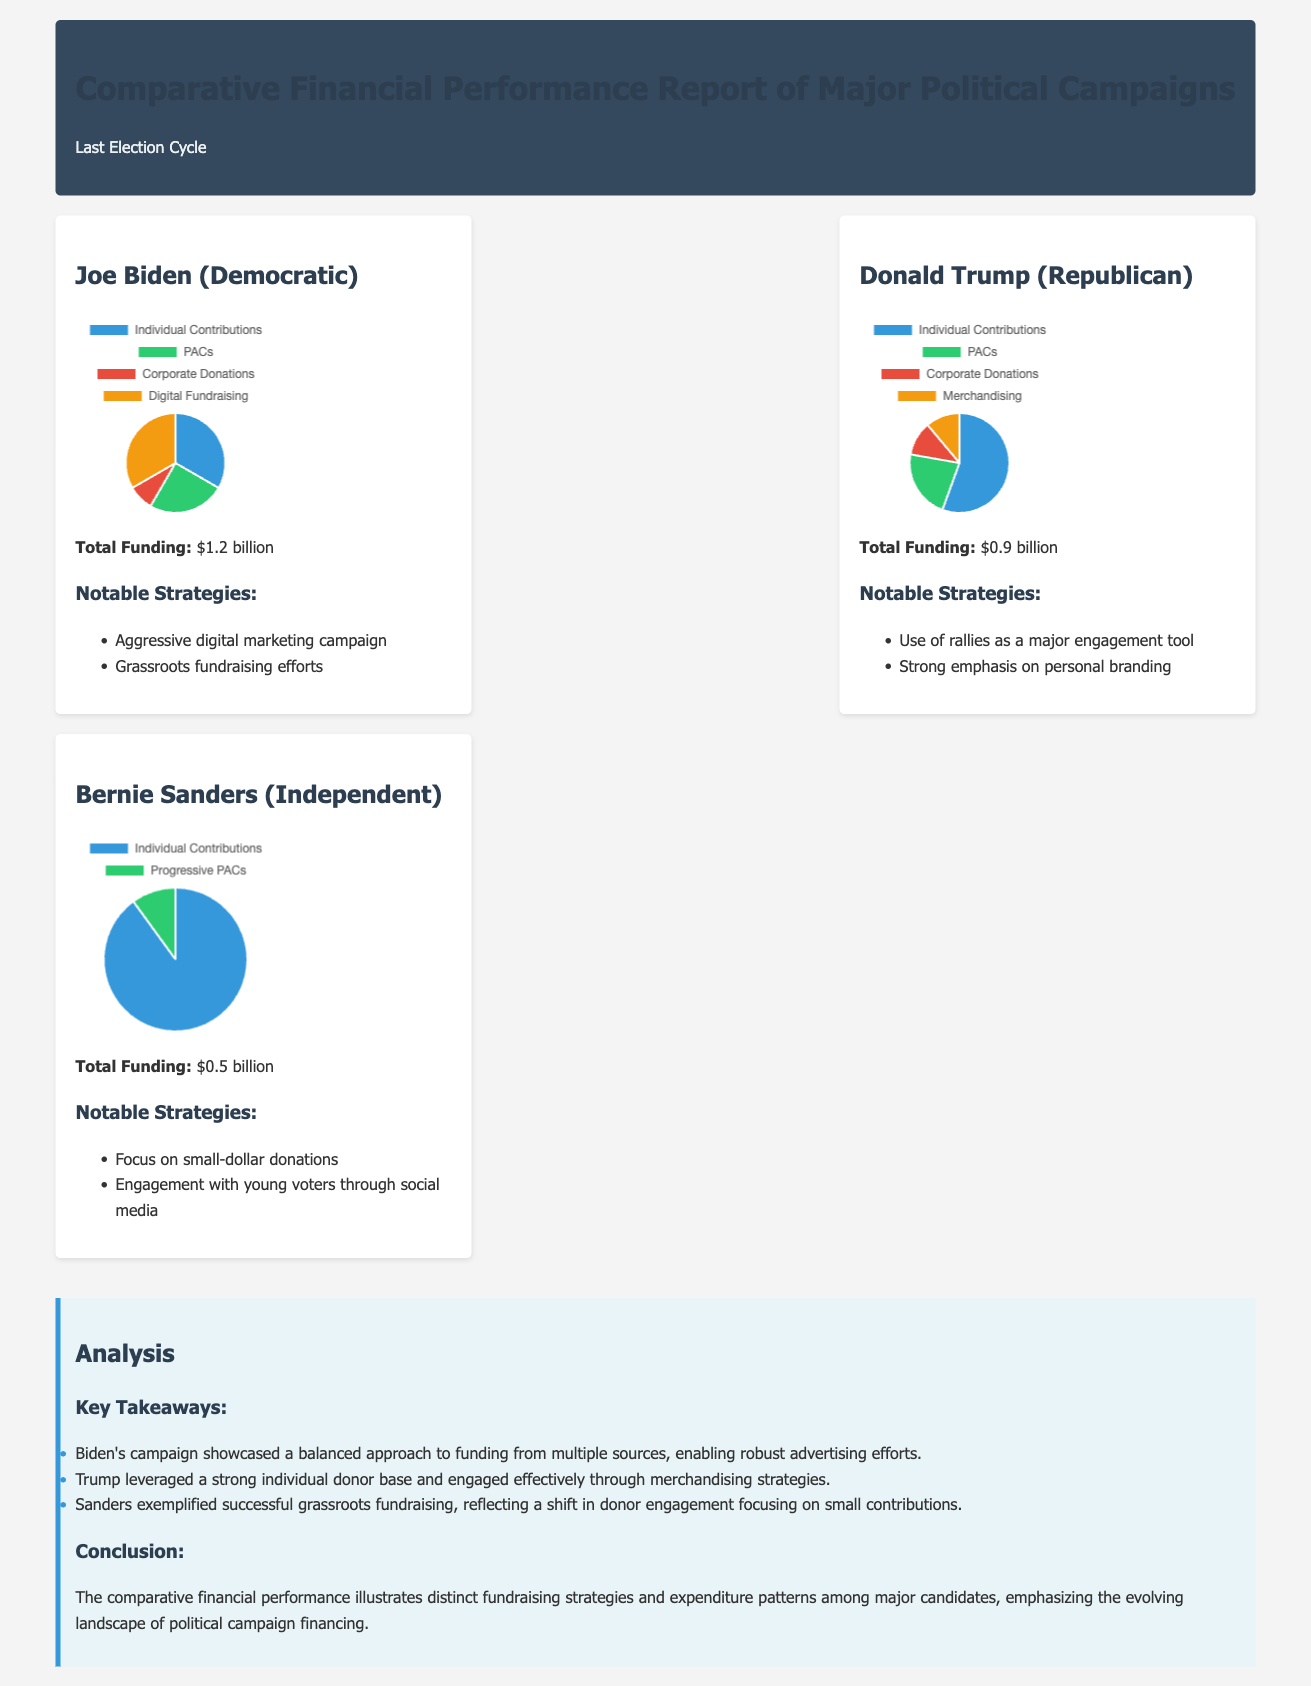What is Joe Biden's total funding? The document states that Joe Biden's total funding is $1.2 billion.
Answer: $1.2 billion What is Donald Trump's notable strategy? One of the notable strategies for Donald Trump's campaign mentioned in the document is the use of rallies as a major engagement tool.
Answer: Use of rallies How much funding did Bernie Sanders receive? According to the document, Bernie Sanders received a total of $0.5 billion in funding.
Answer: $0.5 billion Which candidate had the highest individual contributions? The document indicates that Donald Trump had the highest individual contributions at $500 million.
Answer: Donald Trump What type of funding does Joe Biden rely on most? The document mentions that Joe Biden's campaign funding sources include individual contributions as the largest segment at $400 million.
Answer: Individual contributions What is the primary focus of Bernie Sanders' fundraising strategy? The document states that Bernie Sanders exemplified successful grassroots fundraising focusing on small-dollar donations.
Answer: Small-dollar donations What segment accounted for the least funding in Trump’s campaign? The document notes that the Corporate Donations segment accounted for the least funding, totaling $100 million.
Answer: Corporate Donations What percentage of Biden's funding comes from Digital Fundraising? The document provides that Joe Biden's Digital Fundraising totals $400 million out of $1.2 billion, which is approximately 33%.
Answer: 33% What is the main theme of the analysis section? The analysis section emphasizes the distinct fundraising strategies and expenditure patterns among the major candidates.
Answer: Fundraising strategies and patterns 